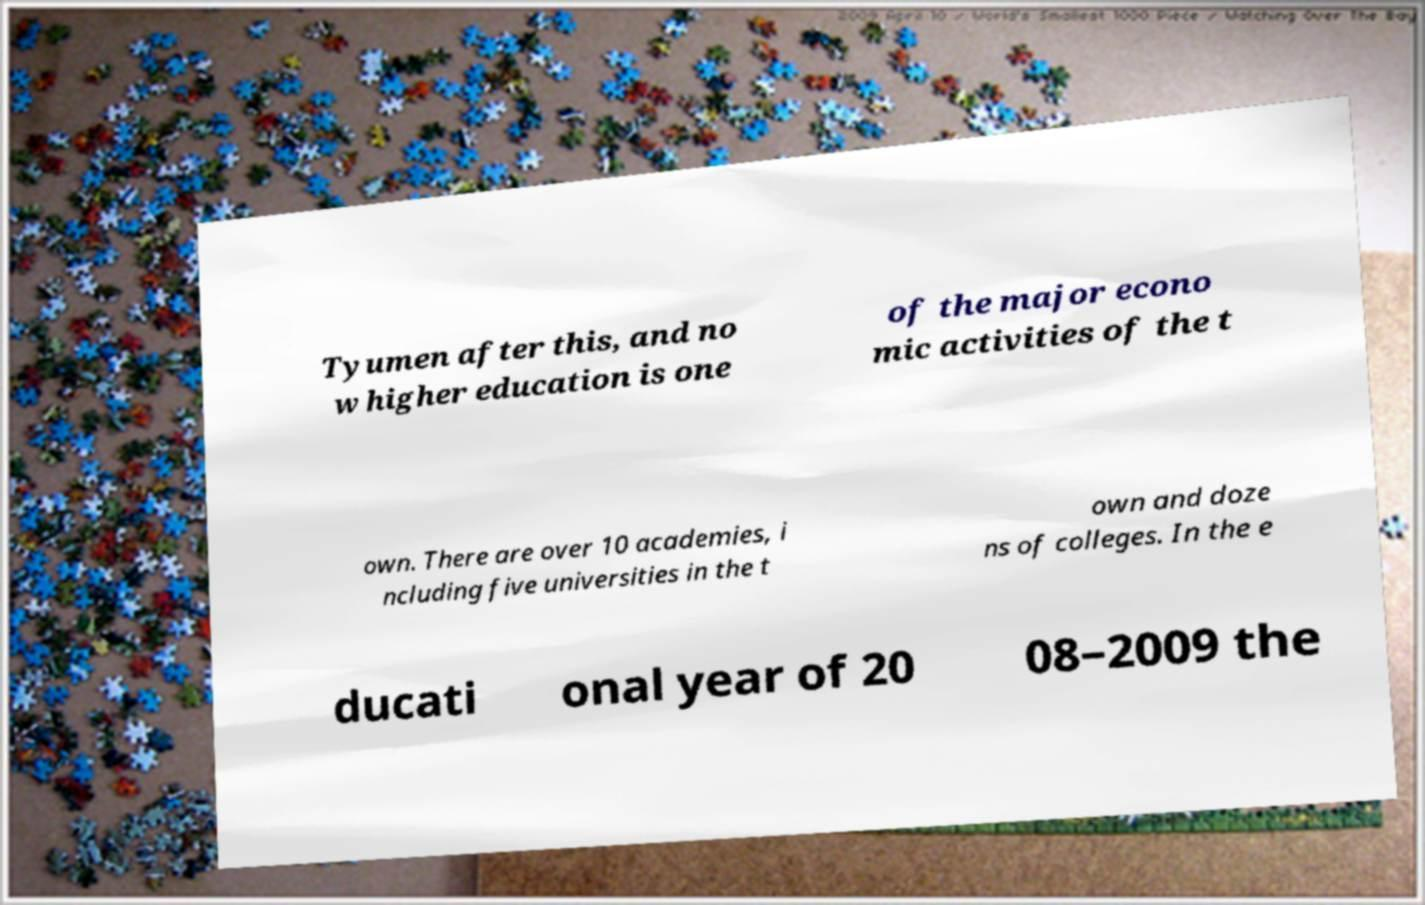I need the written content from this picture converted into text. Can you do that? Tyumen after this, and no w higher education is one of the major econo mic activities of the t own. There are over 10 academies, i ncluding five universities in the t own and doze ns of colleges. In the e ducati onal year of 20 08–2009 the 